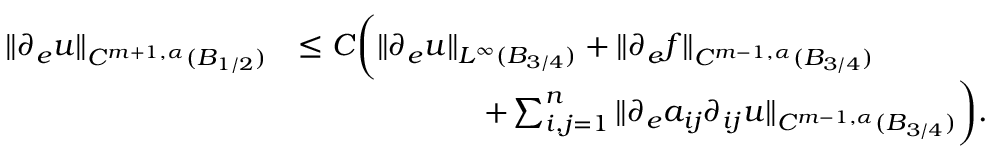Convert formula to latex. <formula><loc_0><loc_0><loc_500><loc_500>\begin{array} { r l } { \| \partial _ { e } u \| _ { C ^ { m + 1 , \alpha } ( B _ { 1 / 2 } ) } } & { \leq C \left ( \| \partial _ { e } u \| _ { L ^ { \infty } ( B _ { 3 / 4 } ) } + \| \partial _ { e } f \| _ { C ^ { m - 1 , \alpha } ( B _ { 3 / 4 } ) } } \\ & { \quad + \sum _ { i , j = 1 } ^ { n } \| \partial _ { e } a _ { i j } \partial _ { i j } u \| _ { C ^ { m - 1 , \alpha } ( B _ { 3 / 4 } ) } \right ) . } \end{array}</formula> 